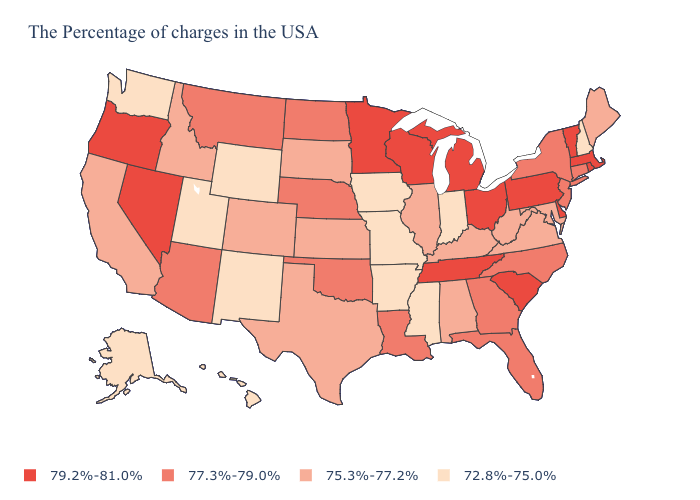Name the states that have a value in the range 77.3%-79.0%?
Concise answer only. Connecticut, New York, New Jersey, North Carolina, Florida, Georgia, Louisiana, Nebraska, Oklahoma, North Dakota, Montana, Arizona. Which states hav the highest value in the MidWest?
Quick response, please. Ohio, Michigan, Wisconsin, Minnesota. What is the value of Wyoming?
Concise answer only. 72.8%-75.0%. Does New Mexico have the same value as Washington?
Concise answer only. Yes. What is the lowest value in the USA?
Keep it brief. 72.8%-75.0%. Among the states that border California , which have the lowest value?
Short answer required. Arizona. Among the states that border Ohio , does Michigan have the lowest value?
Keep it brief. No. What is the highest value in the MidWest ?
Quick response, please. 79.2%-81.0%. Does Tennessee have the highest value in the South?
Answer briefly. Yes. What is the lowest value in the Northeast?
Quick response, please. 72.8%-75.0%. What is the value of Vermont?
Concise answer only. 79.2%-81.0%. Does Hawaii have the lowest value in the USA?
Quick response, please. Yes. Among the states that border Mississippi , does Tennessee have the highest value?
Answer briefly. Yes. What is the highest value in the USA?
Give a very brief answer. 79.2%-81.0%. What is the value of Mississippi?
Quick response, please. 72.8%-75.0%. 